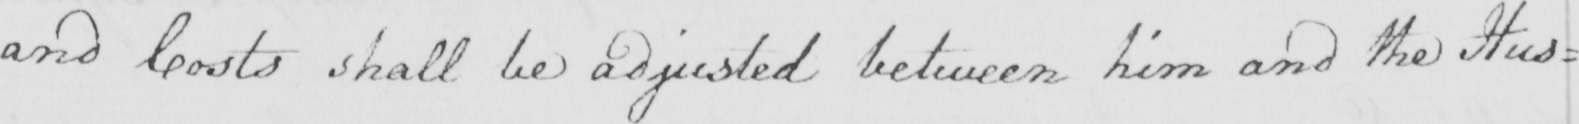Please transcribe the handwritten text in this image. and Costs shall be adjusted between him and the Hus= 